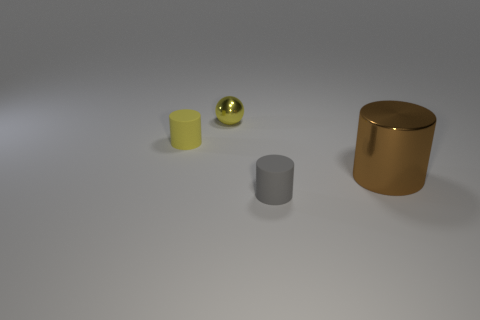Subtract all purple cylinders. Subtract all purple blocks. How many cylinders are left? 3 Add 2 tiny green matte things. How many objects exist? 6 Subtract all balls. How many objects are left? 3 Add 3 small yellow metal blocks. How many small yellow metal blocks exist? 3 Subtract 0 blue spheres. How many objects are left? 4 Subtract all large cyan matte things. Subtract all yellow matte objects. How many objects are left? 3 Add 3 tiny gray rubber things. How many tiny gray rubber things are left? 4 